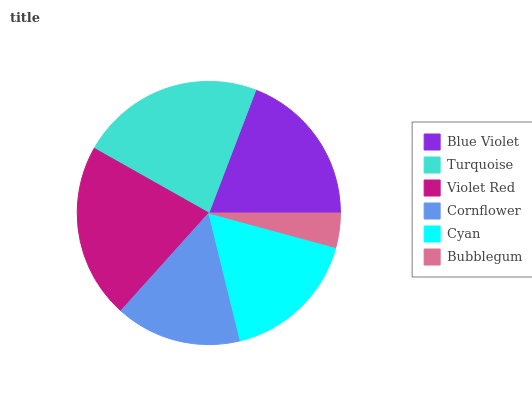Is Bubblegum the minimum?
Answer yes or no. Yes. Is Turquoise the maximum?
Answer yes or no. Yes. Is Violet Red the minimum?
Answer yes or no. No. Is Violet Red the maximum?
Answer yes or no. No. Is Turquoise greater than Violet Red?
Answer yes or no. Yes. Is Violet Red less than Turquoise?
Answer yes or no. Yes. Is Violet Red greater than Turquoise?
Answer yes or no. No. Is Turquoise less than Violet Red?
Answer yes or no. No. Is Blue Violet the high median?
Answer yes or no. Yes. Is Cyan the low median?
Answer yes or no. Yes. Is Turquoise the high median?
Answer yes or no. No. Is Turquoise the low median?
Answer yes or no. No. 